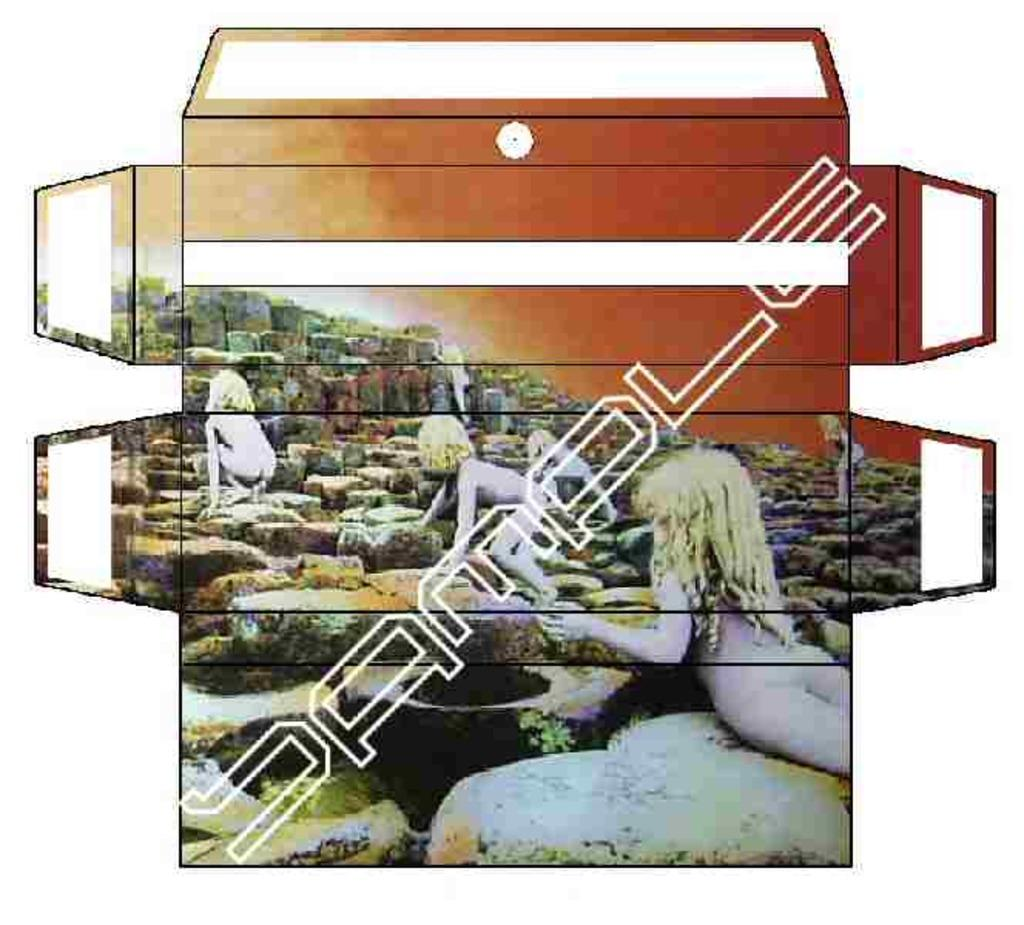What can be seen in the image? There are depictions of persons in the image. What type of cup is being used by the person in the image? There is no cup visible in the image; it only shows depictions of persons. What type of fang can be seen in the image? There are no fangs present in the image; it only shows depictions of persons. 